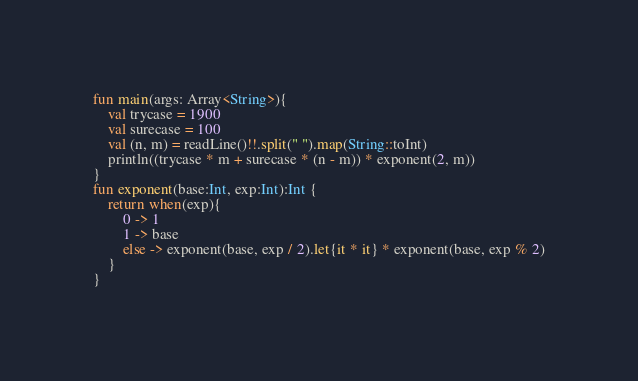<code> <loc_0><loc_0><loc_500><loc_500><_Kotlin_>fun main(args: Array<String>){
    val trycase = 1900
    val surecase = 100
    val (n, m) = readLine()!!.split(" ").map(String::toInt)
    println((trycase * m + surecase * (n - m)) * exponent(2, m))
}
fun exponent(base:Int, exp:Int):Int {
    return when(exp){
        0 -> 1
        1 -> base
        else -> exponent(base, exp / 2).let{it * it} * exponent(base, exp % 2)
    }
}
</code> 